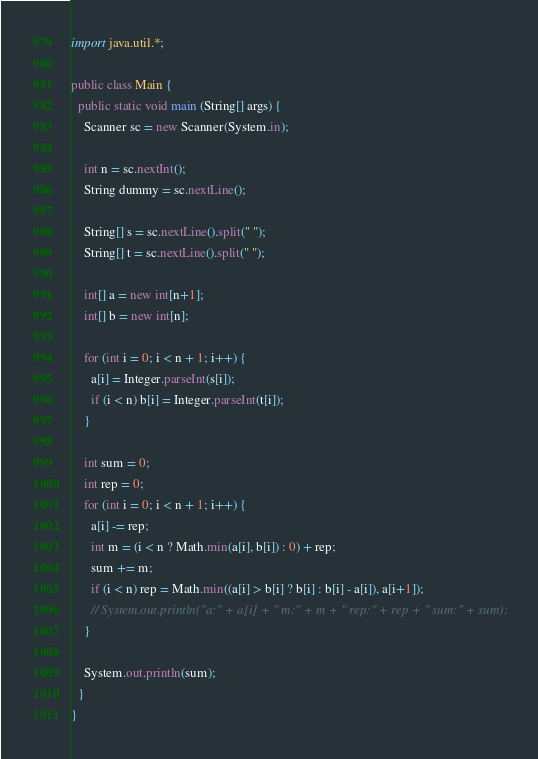Convert code to text. <code><loc_0><loc_0><loc_500><loc_500><_Java_>import java.util.*;

public class Main {
  public static void main (String[] args) {
    Scanner sc = new Scanner(System.in);

    int n = sc.nextInt();
    String dummy = sc.nextLine();

    String[] s = sc.nextLine().split(" ");
    String[] t = sc.nextLine().split(" ");
    
    int[] a = new int[n+1];
    int[] b = new int[n];

    for (int i = 0; i < n + 1; i++) {
      a[i] = Integer.parseInt(s[i]);
      if (i < n) b[i] = Integer.parseInt(t[i]);
    }
    
    int sum = 0;
    int rep = 0;
    for (int i = 0; i < n + 1; i++) {
      a[i] -= rep;
      int m = (i < n ? Math.min(a[i], b[i]) : 0) + rep;
      sum += m;
      if (i < n) rep = Math.min((a[i] > b[i] ? b[i] : b[i] - a[i]), a[i+1]);
      // System.out.println("a:" + a[i] + " m:" + m + " rep:" + rep + " sum:" + sum);
    }
    
    System.out.println(sum);
  }
}
</code> 